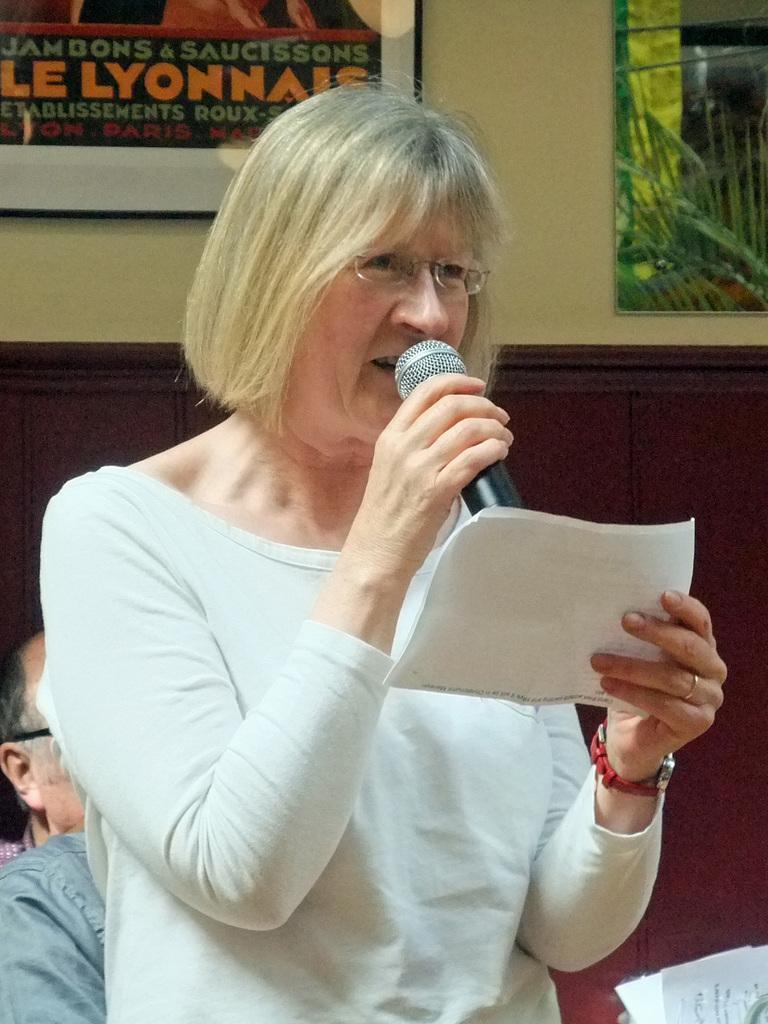Describe this image in one or two sentences. In this image I can see a woman wearing white colored dress is standing and holding a microphone and a paper in her hand. In the background I can see the wall, a frame attached to the wall and few trees. 